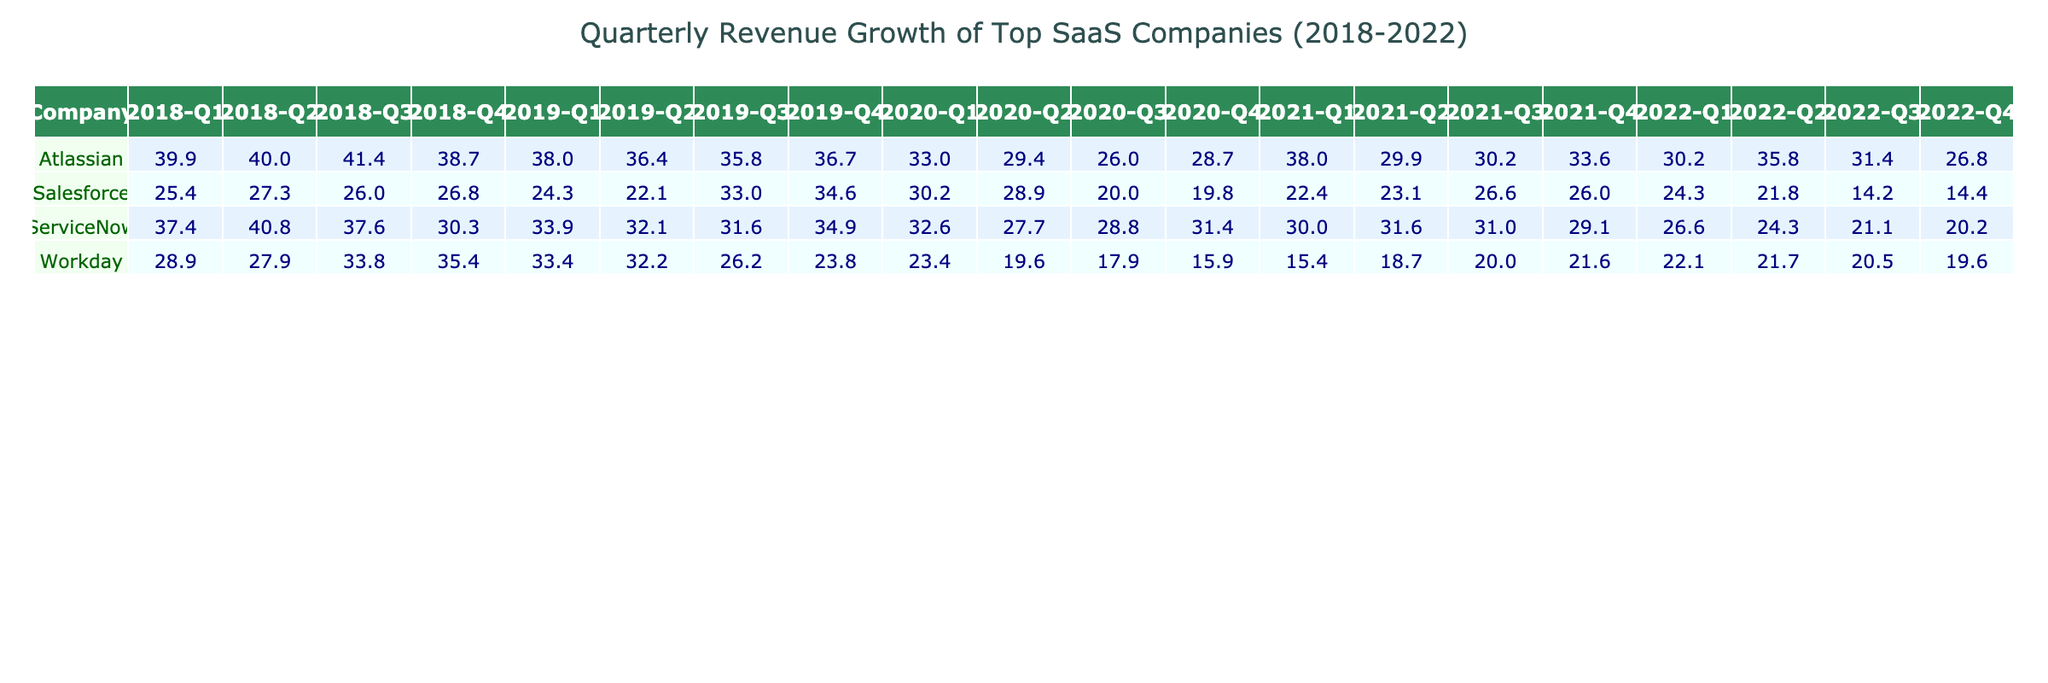What was the revenue growth percentage for Salesforce in Q3 2019? By looking at the table, under the "Salesforce" row and "2019-Q3" column, the value is 33.0%.
Answer: 33.0% Which company had the highest revenue growth in Q2 2018? In the second column for Q2 2018, ServiceNow shows a revenue growth of 40.8%, which is higher than other companies listed.
Answer: ServiceNow What is the average revenue growth for Workday over all quarters in 2021? For Workday in 2021, the quarterly growth percentages are 15.4, 18.7, 20.0, and 21.6. The sum is 15.4 + 18.7 + 20.0 + 21.6 = 75.7, and the average is 75.7 / 4 = 18.925.
Answer: 18.9 Did Atlassian experience any quarter with revenue growth below 30% in 2022? Reviewing the data for Atlassian in 2022, Q4 shows a growth of 26.8%, which is below 30%.
Answer: Yes What was the highest revenue growth for ServiceNow and in which quarter did it occur? The highest revenue growth for ServiceNow listed is 40.8% in Q2 2018.
Answer: 40.8% in Q2 2018 How much did Salesforce's revenue growth decrease from Q1 2020 to Q4 2020? In Q1 2020, Salesforce had a growth of 30.2% and in Q4 2020, it was 19.8%. To find the difference: 30.2 - 19.8 = 10.4%.
Answer: 10.4% Which quarter had the highest overall revenue growth across all companies, based on the table? By comparing all quarters across companies, Q1 2018 for ServiceNow shows the highest growth at 37.4%.
Answer: Q1 2018 How does Atlassian's Q3 2021 revenue growth compare to Salesforce's Q3 2021 growth? Atlassian had a growth of 30.2% in Q3 2021, while Salesforce's growth for the same quarter was 26.6%. Thus, Atlassian's growth was higher by 3.6%.
Answer: 3.6% higher for Atlassian What is the trend in revenue growth for ServiceNow from 2018 to 2022? Reviewing the values, ServiceNow's revenue growth gradually decreased from 37.4% in Q1 2018 to 20.2% in Q4 2022.
Answer: Decreasing trend Was there any quarter in 2020 where Workday's revenue growth was lower than 20%? Yes, in Q4 2020, Workday's revenue growth was 15.9%, which is below 20%.
Answer: Yes 